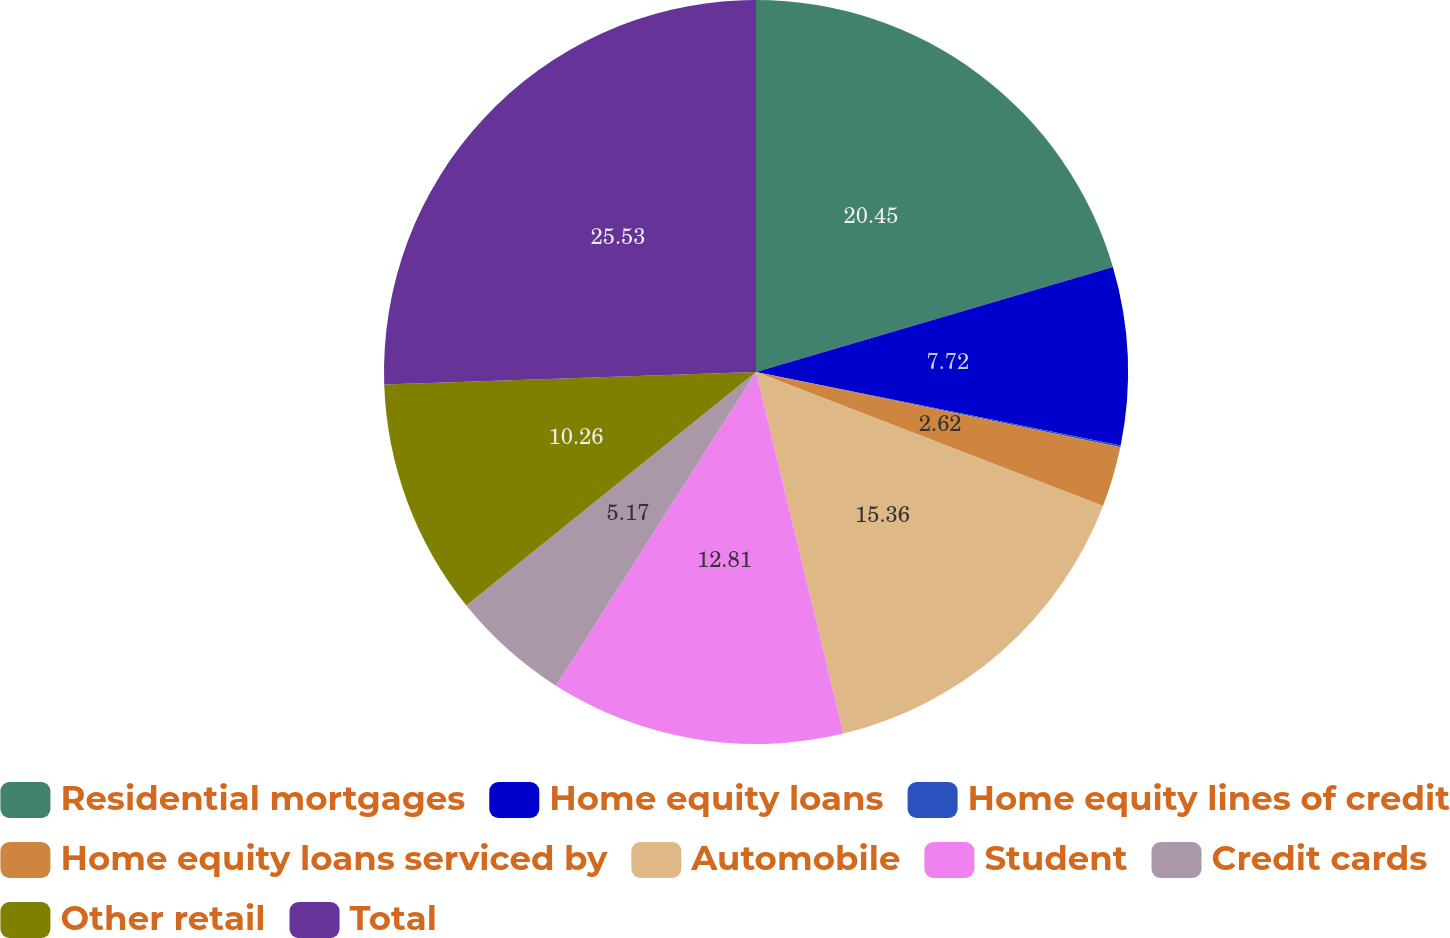Convert chart. <chart><loc_0><loc_0><loc_500><loc_500><pie_chart><fcel>Residential mortgages<fcel>Home equity loans<fcel>Home equity lines of credit<fcel>Home equity loans serviced by<fcel>Automobile<fcel>Student<fcel>Credit cards<fcel>Other retail<fcel>Total<nl><fcel>20.45%<fcel>7.72%<fcel>0.08%<fcel>2.62%<fcel>15.36%<fcel>12.81%<fcel>5.17%<fcel>10.26%<fcel>25.54%<nl></chart> 